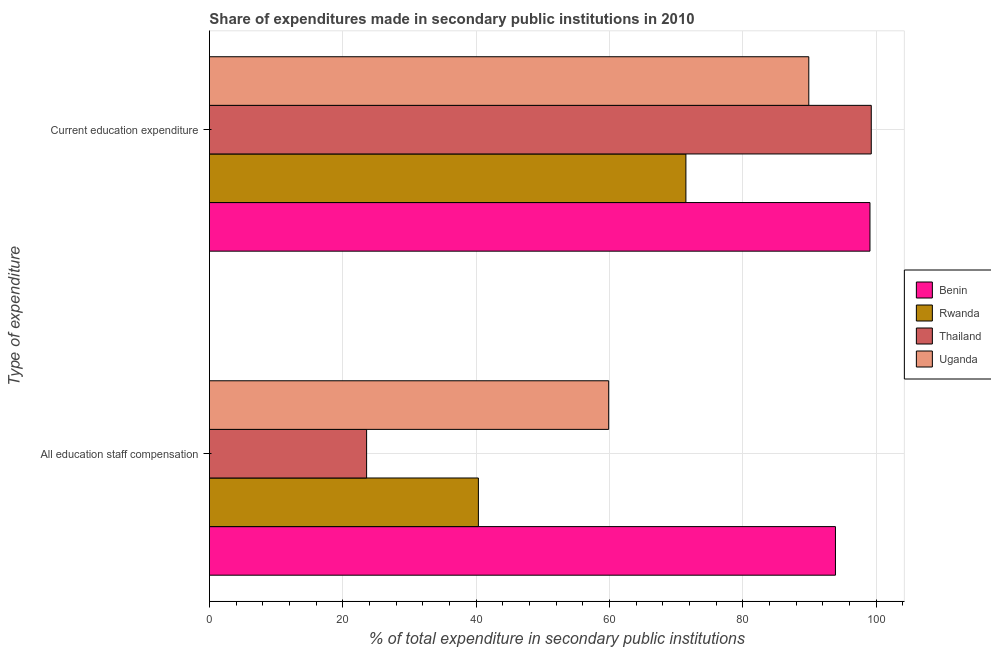How many groups of bars are there?
Provide a succinct answer. 2. Are the number of bars on each tick of the Y-axis equal?
Keep it short and to the point. Yes. How many bars are there on the 1st tick from the top?
Offer a very short reply. 4. What is the label of the 2nd group of bars from the top?
Offer a very short reply. All education staff compensation. What is the expenditure in education in Thailand?
Offer a terse response. 99.29. Across all countries, what is the maximum expenditure in education?
Your answer should be very brief. 99.29. Across all countries, what is the minimum expenditure in education?
Offer a terse response. 71.48. In which country was the expenditure in education maximum?
Give a very brief answer. Thailand. In which country was the expenditure in staff compensation minimum?
Give a very brief answer. Thailand. What is the total expenditure in education in the graph?
Ensure brevity in your answer.  359.77. What is the difference between the expenditure in staff compensation in Benin and that in Rwanda?
Make the answer very short. 53.56. What is the difference between the expenditure in education in Uganda and the expenditure in staff compensation in Rwanda?
Keep it short and to the point. 49.56. What is the average expenditure in education per country?
Give a very brief answer. 89.94. What is the difference between the expenditure in staff compensation and expenditure in education in Rwanda?
Your answer should be compact. -31.13. In how many countries, is the expenditure in education greater than 72 %?
Provide a succinct answer. 3. What is the ratio of the expenditure in education in Thailand to that in Uganda?
Your response must be concise. 1.1. In how many countries, is the expenditure in education greater than the average expenditure in education taken over all countries?
Your answer should be compact. 2. What does the 1st bar from the top in All education staff compensation represents?
Provide a short and direct response. Uganda. What does the 2nd bar from the bottom in Current education expenditure represents?
Make the answer very short. Rwanda. What is the difference between two consecutive major ticks on the X-axis?
Provide a succinct answer. 20. Does the graph contain grids?
Offer a very short reply. Yes. Where does the legend appear in the graph?
Provide a short and direct response. Center right. What is the title of the graph?
Offer a very short reply. Share of expenditures made in secondary public institutions in 2010. Does "Luxembourg" appear as one of the legend labels in the graph?
Your response must be concise. No. What is the label or title of the X-axis?
Ensure brevity in your answer.  % of total expenditure in secondary public institutions. What is the label or title of the Y-axis?
Offer a very short reply. Type of expenditure. What is the % of total expenditure in secondary public institutions in Benin in All education staff compensation?
Your answer should be very brief. 93.91. What is the % of total expenditure in secondary public institutions in Rwanda in All education staff compensation?
Offer a terse response. 40.35. What is the % of total expenditure in secondary public institutions of Thailand in All education staff compensation?
Ensure brevity in your answer.  23.58. What is the % of total expenditure in secondary public institutions of Uganda in All education staff compensation?
Keep it short and to the point. 59.9. What is the % of total expenditure in secondary public institutions of Benin in Current education expenditure?
Your response must be concise. 99.09. What is the % of total expenditure in secondary public institutions in Rwanda in Current education expenditure?
Offer a very short reply. 71.48. What is the % of total expenditure in secondary public institutions in Thailand in Current education expenditure?
Offer a very short reply. 99.29. What is the % of total expenditure in secondary public institutions in Uganda in Current education expenditure?
Your answer should be very brief. 89.91. Across all Type of expenditure, what is the maximum % of total expenditure in secondary public institutions in Benin?
Your answer should be compact. 99.09. Across all Type of expenditure, what is the maximum % of total expenditure in secondary public institutions in Rwanda?
Your answer should be compact. 71.48. Across all Type of expenditure, what is the maximum % of total expenditure in secondary public institutions of Thailand?
Give a very brief answer. 99.29. Across all Type of expenditure, what is the maximum % of total expenditure in secondary public institutions in Uganda?
Keep it short and to the point. 89.91. Across all Type of expenditure, what is the minimum % of total expenditure in secondary public institutions in Benin?
Offer a very short reply. 93.91. Across all Type of expenditure, what is the minimum % of total expenditure in secondary public institutions of Rwanda?
Provide a short and direct response. 40.35. Across all Type of expenditure, what is the minimum % of total expenditure in secondary public institutions of Thailand?
Provide a succinct answer. 23.58. Across all Type of expenditure, what is the minimum % of total expenditure in secondary public institutions of Uganda?
Give a very brief answer. 59.9. What is the total % of total expenditure in secondary public institutions in Benin in the graph?
Keep it short and to the point. 193.01. What is the total % of total expenditure in secondary public institutions of Rwanda in the graph?
Ensure brevity in your answer.  111.83. What is the total % of total expenditure in secondary public institutions of Thailand in the graph?
Give a very brief answer. 122.87. What is the total % of total expenditure in secondary public institutions in Uganda in the graph?
Your response must be concise. 149.81. What is the difference between the % of total expenditure in secondary public institutions of Benin in All education staff compensation and that in Current education expenditure?
Make the answer very short. -5.18. What is the difference between the % of total expenditure in secondary public institutions of Rwanda in All education staff compensation and that in Current education expenditure?
Your answer should be compact. -31.13. What is the difference between the % of total expenditure in secondary public institutions of Thailand in All education staff compensation and that in Current education expenditure?
Provide a short and direct response. -75.7. What is the difference between the % of total expenditure in secondary public institutions of Uganda in All education staff compensation and that in Current education expenditure?
Your answer should be compact. -30.02. What is the difference between the % of total expenditure in secondary public institutions in Benin in All education staff compensation and the % of total expenditure in secondary public institutions in Rwanda in Current education expenditure?
Offer a terse response. 22.43. What is the difference between the % of total expenditure in secondary public institutions of Benin in All education staff compensation and the % of total expenditure in secondary public institutions of Thailand in Current education expenditure?
Your response must be concise. -5.37. What is the difference between the % of total expenditure in secondary public institutions in Benin in All education staff compensation and the % of total expenditure in secondary public institutions in Uganda in Current education expenditure?
Your answer should be compact. 4. What is the difference between the % of total expenditure in secondary public institutions in Rwanda in All education staff compensation and the % of total expenditure in secondary public institutions in Thailand in Current education expenditure?
Your answer should be very brief. -58.94. What is the difference between the % of total expenditure in secondary public institutions of Rwanda in All education staff compensation and the % of total expenditure in secondary public institutions of Uganda in Current education expenditure?
Give a very brief answer. -49.56. What is the difference between the % of total expenditure in secondary public institutions of Thailand in All education staff compensation and the % of total expenditure in secondary public institutions of Uganda in Current education expenditure?
Your response must be concise. -66.33. What is the average % of total expenditure in secondary public institutions in Benin per Type of expenditure?
Make the answer very short. 96.5. What is the average % of total expenditure in secondary public institutions in Rwanda per Type of expenditure?
Provide a succinct answer. 55.92. What is the average % of total expenditure in secondary public institutions of Thailand per Type of expenditure?
Ensure brevity in your answer.  61.43. What is the average % of total expenditure in secondary public institutions in Uganda per Type of expenditure?
Your answer should be very brief. 74.91. What is the difference between the % of total expenditure in secondary public institutions of Benin and % of total expenditure in secondary public institutions of Rwanda in All education staff compensation?
Offer a terse response. 53.56. What is the difference between the % of total expenditure in secondary public institutions of Benin and % of total expenditure in secondary public institutions of Thailand in All education staff compensation?
Offer a very short reply. 70.33. What is the difference between the % of total expenditure in secondary public institutions in Benin and % of total expenditure in secondary public institutions in Uganda in All education staff compensation?
Offer a terse response. 34.02. What is the difference between the % of total expenditure in secondary public institutions in Rwanda and % of total expenditure in secondary public institutions in Thailand in All education staff compensation?
Your response must be concise. 16.77. What is the difference between the % of total expenditure in secondary public institutions in Rwanda and % of total expenditure in secondary public institutions in Uganda in All education staff compensation?
Your answer should be very brief. -19.55. What is the difference between the % of total expenditure in secondary public institutions in Thailand and % of total expenditure in secondary public institutions in Uganda in All education staff compensation?
Your answer should be very brief. -36.31. What is the difference between the % of total expenditure in secondary public institutions of Benin and % of total expenditure in secondary public institutions of Rwanda in Current education expenditure?
Provide a succinct answer. 27.61. What is the difference between the % of total expenditure in secondary public institutions in Benin and % of total expenditure in secondary public institutions in Thailand in Current education expenditure?
Offer a very short reply. -0.19. What is the difference between the % of total expenditure in secondary public institutions in Benin and % of total expenditure in secondary public institutions in Uganda in Current education expenditure?
Make the answer very short. 9.18. What is the difference between the % of total expenditure in secondary public institutions in Rwanda and % of total expenditure in secondary public institutions in Thailand in Current education expenditure?
Your answer should be very brief. -27.81. What is the difference between the % of total expenditure in secondary public institutions in Rwanda and % of total expenditure in secondary public institutions in Uganda in Current education expenditure?
Your answer should be compact. -18.43. What is the difference between the % of total expenditure in secondary public institutions of Thailand and % of total expenditure in secondary public institutions of Uganda in Current education expenditure?
Provide a short and direct response. 9.37. What is the ratio of the % of total expenditure in secondary public institutions in Benin in All education staff compensation to that in Current education expenditure?
Make the answer very short. 0.95. What is the ratio of the % of total expenditure in secondary public institutions in Rwanda in All education staff compensation to that in Current education expenditure?
Your response must be concise. 0.56. What is the ratio of the % of total expenditure in secondary public institutions in Thailand in All education staff compensation to that in Current education expenditure?
Your answer should be very brief. 0.24. What is the ratio of the % of total expenditure in secondary public institutions of Uganda in All education staff compensation to that in Current education expenditure?
Make the answer very short. 0.67. What is the difference between the highest and the second highest % of total expenditure in secondary public institutions of Benin?
Give a very brief answer. 5.18. What is the difference between the highest and the second highest % of total expenditure in secondary public institutions of Rwanda?
Offer a very short reply. 31.13. What is the difference between the highest and the second highest % of total expenditure in secondary public institutions of Thailand?
Ensure brevity in your answer.  75.7. What is the difference between the highest and the second highest % of total expenditure in secondary public institutions of Uganda?
Offer a terse response. 30.02. What is the difference between the highest and the lowest % of total expenditure in secondary public institutions of Benin?
Ensure brevity in your answer.  5.18. What is the difference between the highest and the lowest % of total expenditure in secondary public institutions of Rwanda?
Your answer should be compact. 31.13. What is the difference between the highest and the lowest % of total expenditure in secondary public institutions in Thailand?
Offer a very short reply. 75.7. What is the difference between the highest and the lowest % of total expenditure in secondary public institutions in Uganda?
Make the answer very short. 30.02. 